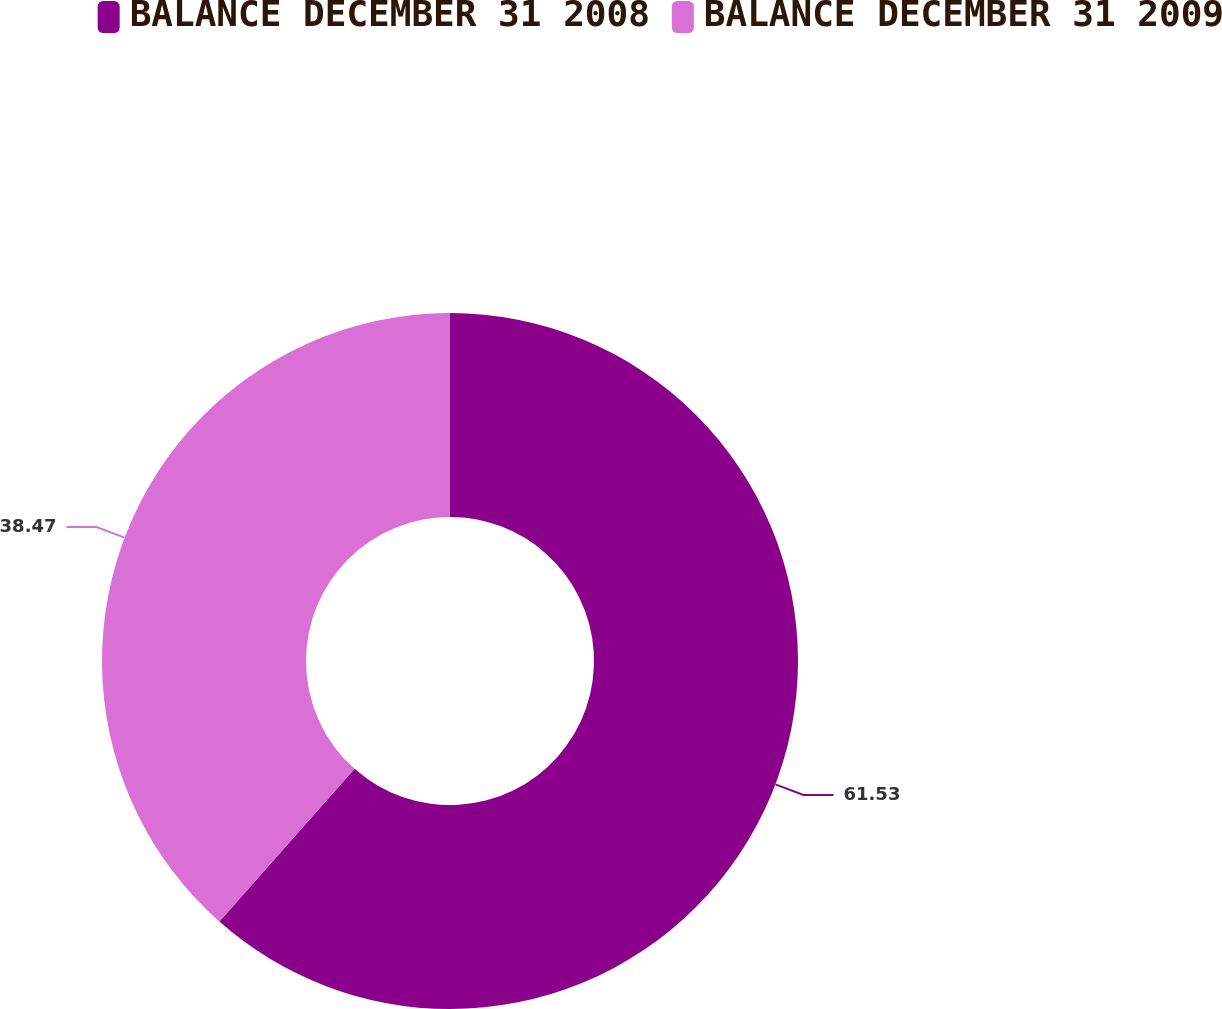Convert chart to OTSL. <chart><loc_0><loc_0><loc_500><loc_500><pie_chart><fcel>BALANCE DECEMBER 31 2008<fcel>BALANCE DECEMBER 31 2009<nl><fcel>61.53%<fcel>38.47%<nl></chart> 